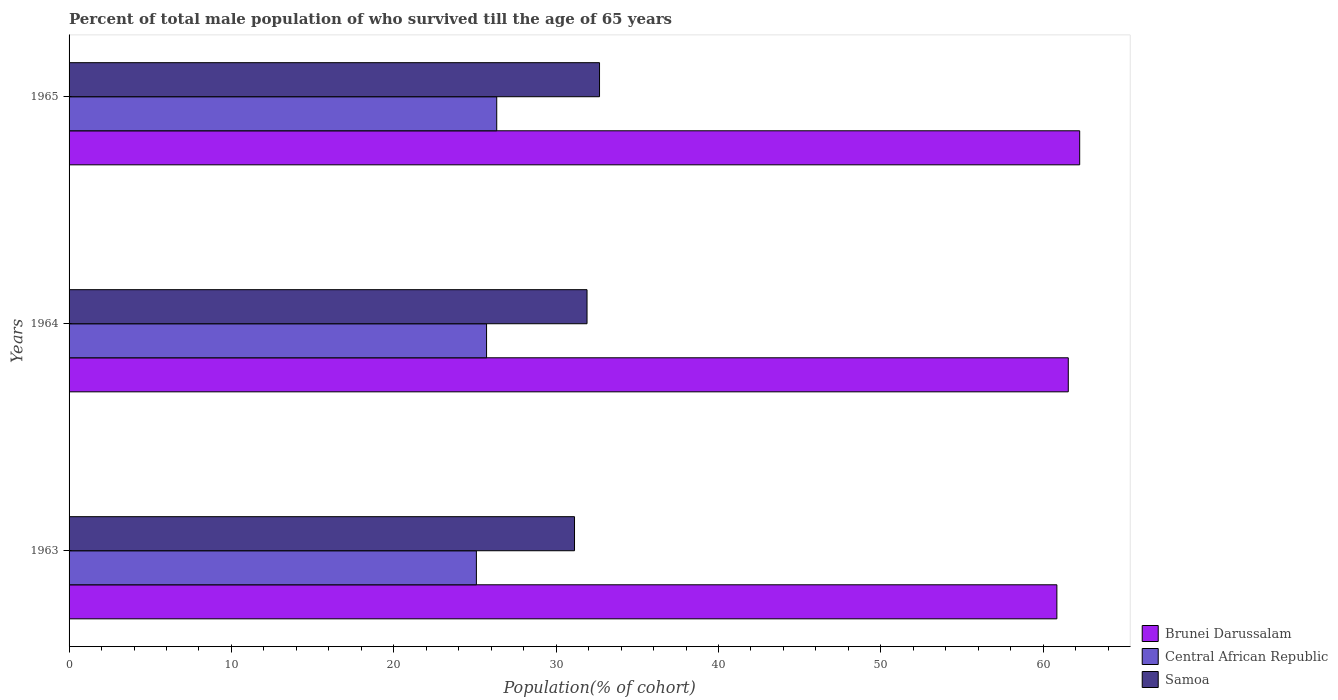How many different coloured bars are there?
Your answer should be very brief. 3. How many groups of bars are there?
Ensure brevity in your answer.  3. Are the number of bars per tick equal to the number of legend labels?
Keep it short and to the point. Yes. Are the number of bars on each tick of the Y-axis equal?
Keep it short and to the point. Yes. What is the label of the 3rd group of bars from the top?
Offer a very short reply. 1963. What is the percentage of total male population who survived till the age of 65 years in Samoa in 1963?
Your answer should be very brief. 31.13. Across all years, what is the maximum percentage of total male population who survived till the age of 65 years in Central African Republic?
Make the answer very short. 26.34. Across all years, what is the minimum percentage of total male population who survived till the age of 65 years in Central African Republic?
Keep it short and to the point. 25.09. In which year was the percentage of total male population who survived till the age of 65 years in Central African Republic maximum?
Give a very brief answer. 1965. In which year was the percentage of total male population who survived till the age of 65 years in Samoa minimum?
Offer a very short reply. 1963. What is the total percentage of total male population who survived till the age of 65 years in Central African Republic in the graph?
Offer a terse response. 77.15. What is the difference between the percentage of total male population who survived till the age of 65 years in Samoa in 1963 and that in 1964?
Provide a succinct answer. -0.77. What is the difference between the percentage of total male population who survived till the age of 65 years in Samoa in 1965 and the percentage of total male population who survived till the age of 65 years in Central African Republic in 1963?
Your response must be concise. 7.59. What is the average percentage of total male population who survived till the age of 65 years in Central African Republic per year?
Provide a succinct answer. 25.72. In the year 1963, what is the difference between the percentage of total male population who survived till the age of 65 years in Brunei Darussalam and percentage of total male population who survived till the age of 65 years in Central African Republic?
Your answer should be compact. 35.75. What is the ratio of the percentage of total male population who survived till the age of 65 years in Central African Republic in 1964 to that in 1965?
Ensure brevity in your answer.  0.98. Is the percentage of total male population who survived till the age of 65 years in Samoa in 1963 less than that in 1964?
Ensure brevity in your answer.  Yes. What is the difference between the highest and the second highest percentage of total male population who survived till the age of 65 years in Central African Republic?
Make the answer very short. 0.63. What is the difference between the highest and the lowest percentage of total male population who survived till the age of 65 years in Samoa?
Give a very brief answer. 1.54. In how many years, is the percentage of total male population who survived till the age of 65 years in Brunei Darussalam greater than the average percentage of total male population who survived till the age of 65 years in Brunei Darussalam taken over all years?
Offer a terse response. 1. Is the sum of the percentage of total male population who survived till the age of 65 years in Central African Republic in 1963 and 1964 greater than the maximum percentage of total male population who survived till the age of 65 years in Brunei Darussalam across all years?
Provide a short and direct response. No. What does the 2nd bar from the top in 1964 represents?
Provide a short and direct response. Central African Republic. What does the 3rd bar from the bottom in 1964 represents?
Keep it short and to the point. Samoa. How many years are there in the graph?
Offer a terse response. 3. What is the difference between two consecutive major ticks on the X-axis?
Your answer should be compact. 10. Where does the legend appear in the graph?
Your answer should be very brief. Bottom right. How many legend labels are there?
Make the answer very short. 3. What is the title of the graph?
Your answer should be very brief. Percent of total male population of who survived till the age of 65 years. Does "Liechtenstein" appear as one of the legend labels in the graph?
Your response must be concise. No. What is the label or title of the X-axis?
Offer a very short reply. Population(% of cohort). What is the Population(% of cohort) of Brunei Darussalam in 1963?
Provide a short and direct response. 60.84. What is the Population(% of cohort) in Central African Republic in 1963?
Offer a terse response. 25.09. What is the Population(% of cohort) of Samoa in 1963?
Offer a very short reply. 31.13. What is the Population(% of cohort) of Brunei Darussalam in 1964?
Provide a short and direct response. 61.55. What is the Population(% of cohort) of Central African Republic in 1964?
Provide a short and direct response. 25.72. What is the Population(% of cohort) in Samoa in 1964?
Provide a succinct answer. 31.9. What is the Population(% of cohort) in Brunei Darussalam in 1965?
Offer a very short reply. 62.25. What is the Population(% of cohort) in Central African Republic in 1965?
Make the answer very short. 26.34. What is the Population(% of cohort) of Samoa in 1965?
Provide a short and direct response. 32.67. Across all years, what is the maximum Population(% of cohort) in Brunei Darussalam?
Give a very brief answer. 62.25. Across all years, what is the maximum Population(% of cohort) in Central African Republic?
Keep it short and to the point. 26.34. Across all years, what is the maximum Population(% of cohort) in Samoa?
Offer a terse response. 32.67. Across all years, what is the minimum Population(% of cohort) of Brunei Darussalam?
Offer a terse response. 60.84. Across all years, what is the minimum Population(% of cohort) of Central African Republic?
Make the answer very short. 25.09. Across all years, what is the minimum Population(% of cohort) of Samoa?
Ensure brevity in your answer.  31.13. What is the total Population(% of cohort) in Brunei Darussalam in the graph?
Provide a short and direct response. 184.64. What is the total Population(% of cohort) in Central African Republic in the graph?
Provide a succinct answer. 77.15. What is the total Population(% of cohort) of Samoa in the graph?
Make the answer very short. 95.71. What is the difference between the Population(% of cohort) in Brunei Darussalam in 1963 and that in 1964?
Ensure brevity in your answer.  -0.7. What is the difference between the Population(% of cohort) in Central African Republic in 1963 and that in 1964?
Provide a succinct answer. -0.63. What is the difference between the Population(% of cohort) of Samoa in 1963 and that in 1964?
Offer a very short reply. -0.77. What is the difference between the Population(% of cohort) in Brunei Darussalam in 1963 and that in 1965?
Keep it short and to the point. -1.4. What is the difference between the Population(% of cohort) in Central African Republic in 1963 and that in 1965?
Provide a succinct answer. -1.25. What is the difference between the Population(% of cohort) in Samoa in 1963 and that in 1965?
Offer a terse response. -1.54. What is the difference between the Population(% of cohort) in Brunei Darussalam in 1964 and that in 1965?
Offer a very short reply. -0.7. What is the difference between the Population(% of cohort) of Central African Republic in 1964 and that in 1965?
Your response must be concise. -0.63. What is the difference between the Population(% of cohort) of Samoa in 1964 and that in 1965?
Give a very brief answer. -0.77. What is the difference between the Population(% of cohort) in Brunei Darussalam in 1963 and the Population(% of cohort) in Central African Republic in 1964?
Your answer should be very brief. 35.13. What is the difference between the Population(% of cohort) in Brunei Darussalam in 1963 and the Population(% of cohort) in Samoa in 1964?
Make the answer very short. 28.94. What is the difference between the Population(% of cohort) of Central African Republic in 1963 and the Population(% of cohort) of Samoa in 1964?
Ensure brevity in your answer.  -6.81. What is the difference between the Population(% of cohort) in Brunei Darussalam in 1963 and the Population(% of cohort) in Central African Republic in 1965?
Provide a succinct answer. 34.5. What is the difference between the Population(% of cohort) of Brunei Darussalam in 1963 and the Population(% of cohort) of Samoa in 1965?
Your answer should be very brief. 28.17. What is the difference between the Population(% of cohort) in Central African Republic in 1963 and the Population(% of cohort) in Samoa in 1965?
Provide a succinct answer. -7.59. What is the difference between the Population(% of cohort) of Brunei Darussalam in 1964 and the Population(% of cohort) of Central African Republic in 1965?
Offer a terse response. 35.2. What is the difference between the Population(% of cohort) in Brunei Darussalam in 1964 and the Population(% of cohort) in Samoa in 1965?
Your answer should be very brief. 28.87. What is the difference between the Population(% of cohort) in Central African Republic in 1964 and the Population(% of cohort) in Samoa in 1965?
Offer a terse response. -6.96. What is the average Population(% of cohort) of Brunei Darussalam per year?
Ensure brevity in your answer.  61.55. What is the average Population(% of cohort) of Central African Republic per year?
Provide a succinct answer. 25.72. What is the average Population(% of cohort) of Samoa per year?
Provide a short and direct response. 31.9. In the year 1963, what is the difference between the Population(% of cohort) in Brunei Darussalam and Population(% of cohort) in Central African Republic?
Keep it short and to the point. 35.75. In the year 1963, what is the difference between the Population(% of cohort) in Brunei Darussalam and Population(% of cohort) in Samoa?
Provide a short and direct response. 29.71. In the year 1963, what is the difference between the Population(% of cohort) of Central African Republic and Population(% of cohort) of Samoa?
Ensure brevity in your answer.  -6.04. In the year 1964, what is the difference between the Population(% of cohort) of Brunei Darussalam and Population(% of cohort) of Central African Republic?
Offer a very short reply. 35.83. In the year 1964, what is the difference between the Population(% of cohort) in Brunei Darussalam and Population(% of cohort) in Samoa?
Keep it short and to the point. 29.64. In the year 1964, what is the difference between the Population(% of cohort) in Central African Republic and Population(% of cohort) in Samoa?
Ensure brevity in your answer.  -6.19. In the year 1965, what is the difference between the Population(% of cohort) in Brunei Darussalam and Population(% of cohort) in Central African Republic?
Ensure brevity in your answer.  35.91. In the year 1965, what is the difference between the Population(% of cohort) in Brunei Darussalam and Population(% of cohort) in Samoa?
Offer a terse response. 29.57. In the year 1965, what is the difference between the Population(% of cohort) of Central African Republic and Population(% of cohort) of Samoa?
Offer a terse response. -6.33. What is the ratio of the Population(% of cohort) in Central African Republic in 1963 to that in 1964?
Your response must be concise. 0.98. What is the ratio of the Population(% of cohort) of Samoa in 1963 to that in 1964?
Your response must be concise. 0.98. What is the ratio of the Population(% of cohort) in Brunei Darussalam in 1963 to that in 1965?
Make the answer very short. 0.98. What is the ratio of the Population(% of cohort) of Central African Republic in 1963 to that in 1965?
Your answer should be very brief. 0.95. What is the ratio of the Population(% of cohort) of Samoa in 1963 to that in 1965?
Offer a very short reply. 0.95. What is the ratio of the Population(% of cohort) of Brunei Darussalam in 1964 to that in 1965?
Make the answer very short. 0.99. What is the ratio of the Population(% of cohort) of Central African Republic in 1964 to that in 1965?
Your answer should be compact. 0.98. What is the ratio of the Population(% of cohort) of Samoa in 1964 to that in 1965?
Ensure brevity in your answer.  0.98. What is the difference between the highest and the second highest Population(% of cohort) in Brunei Darussalam?
Your answer should be very brief. 0.7. What is the difference between the highest and the second highest Population(% of cohort) in Central African Republic?
Keep it short and to the point. 0.63. What is the difference between the highest and the second highest Population(% of cohort) of Samoa?
Your answer should be compact. 0.77. What is the difference between the highest and the lowest Population(% of cohort) of Brunei Darussalam?
Keep it short and to the point. 1.4. What is the difference between the highest and the lowest Population(% of cohort) of Central African Republic?
Make the answer very short. 1.25. What is the difference between the highest and the lowest Population(% of cohort) in Samoa?
Your response must be concise. 1.54. 